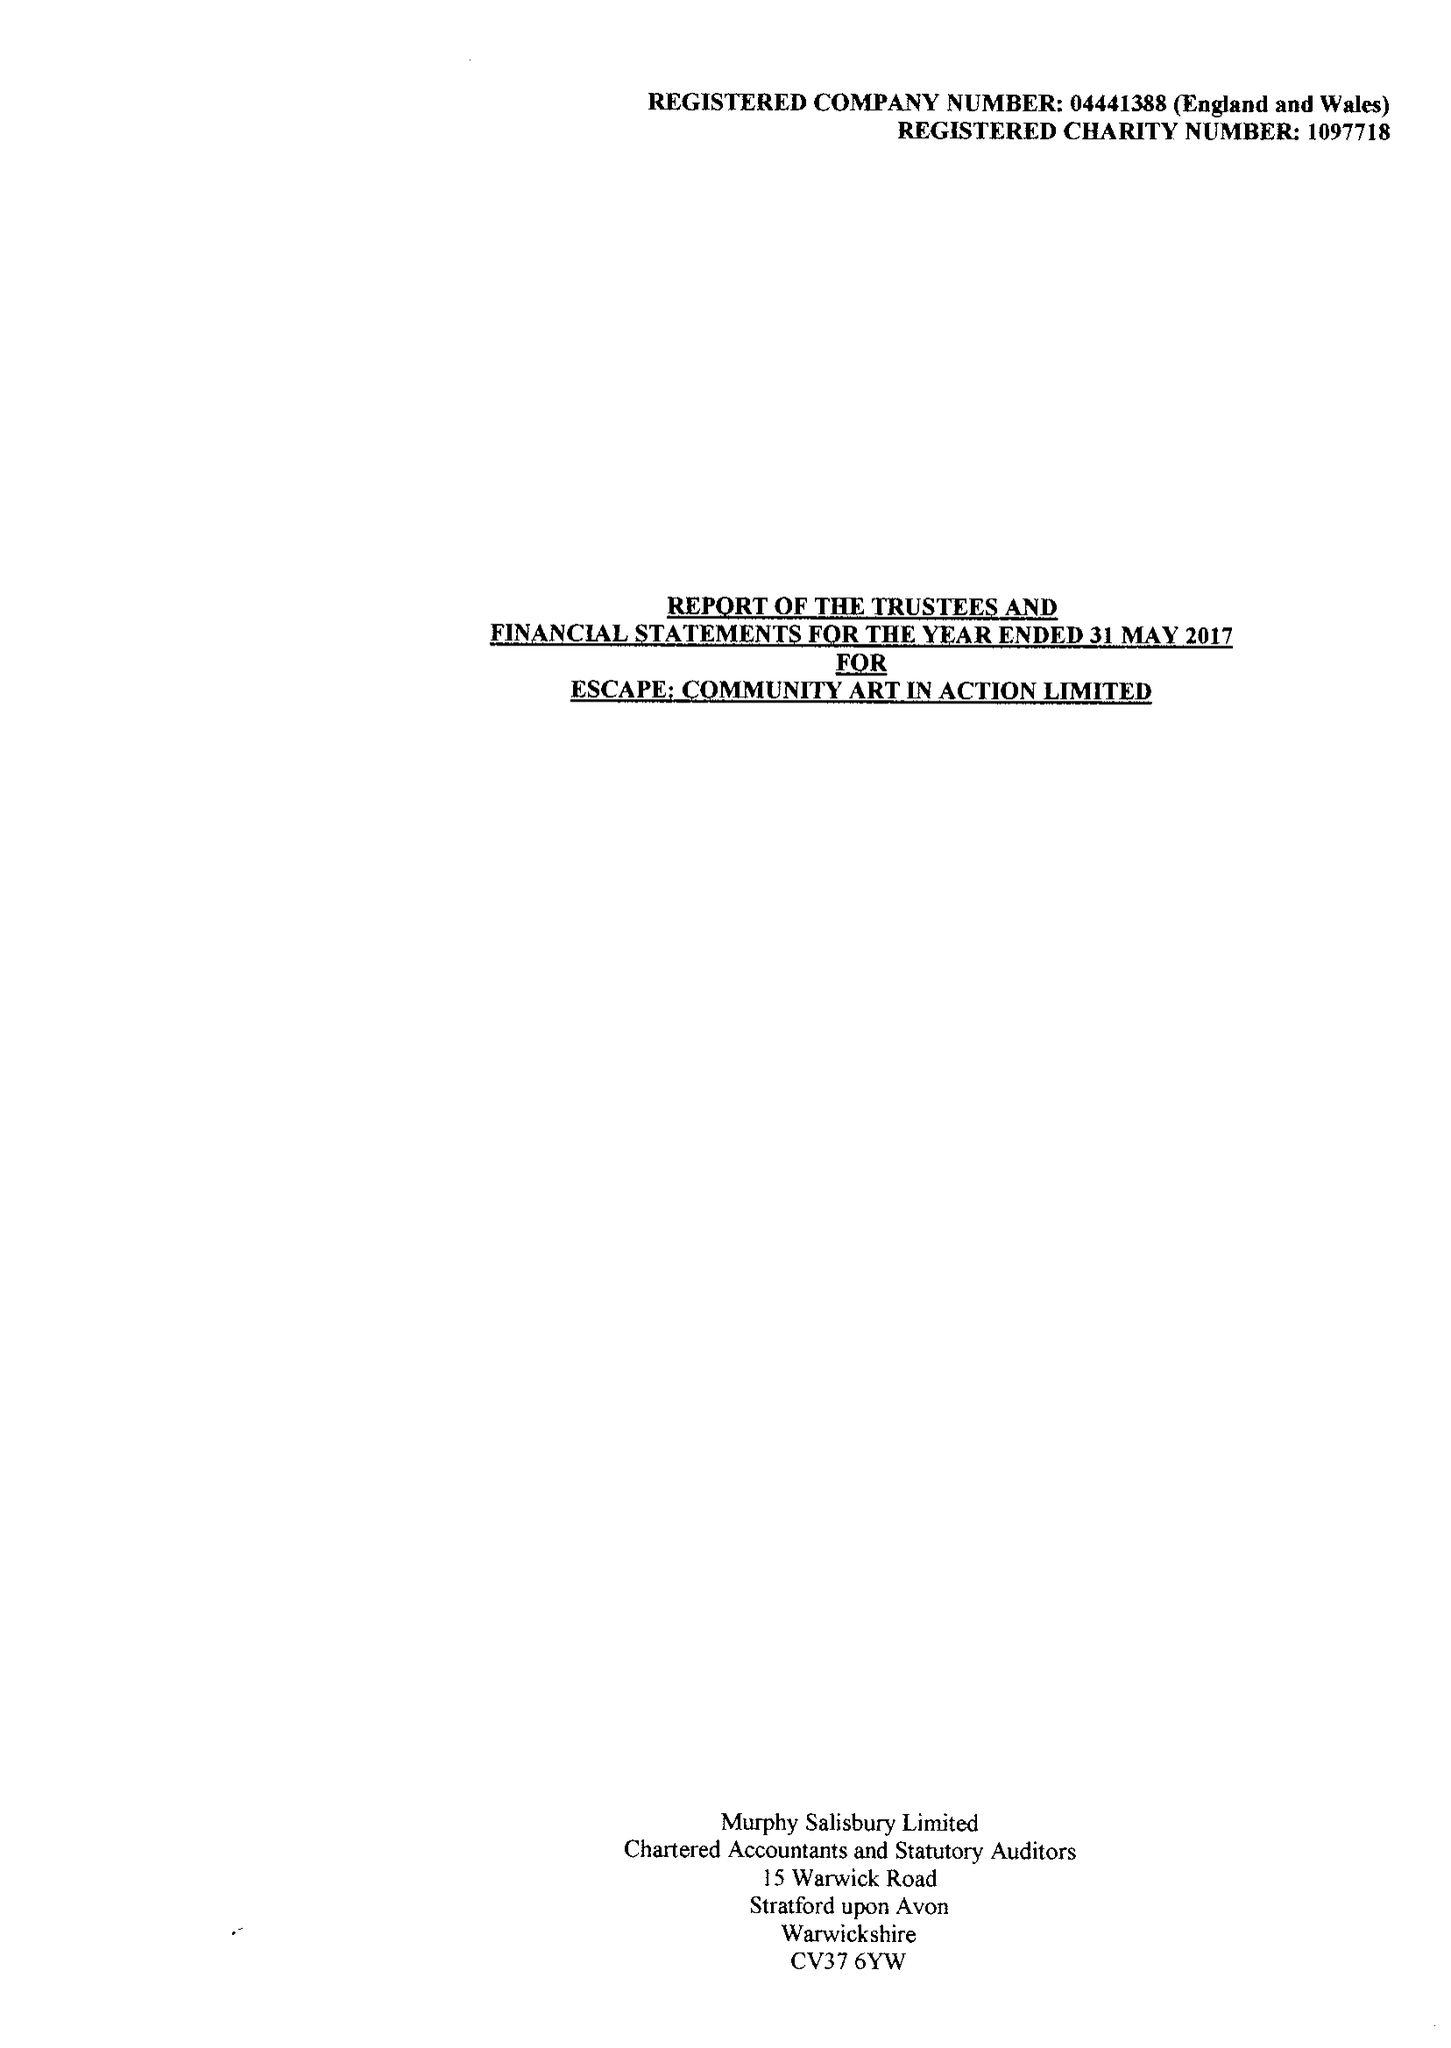What is the value for the address__postcode?
Answer the question using a single word or phrase. CV37 6EE 